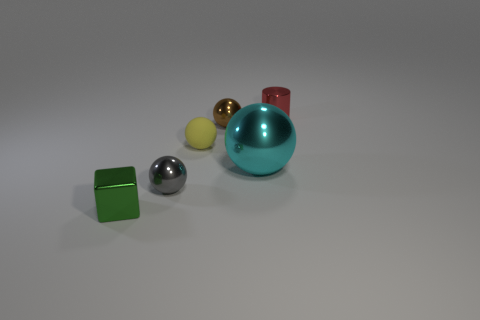Is there any other thing that is the same material as the small yellow thing?
Offer a terse response. No. Is the size of the ball that is to the right of the tiny brown sphere the same as the sphere that is behind the yellow sphere?
Your answer should be compact. No. Are there any red shiny objects of the same size as the cyan thing?
Your answer should be compact. No. Do the thing that is left of the tiny gray thing and the big cyan object have the same shape?
Give a very brief answer. No. What is the thing that is in front of the small gray ball made of?
Keep it short and to the point. Metal. What is the shape of the thing behind the tiny metal ball to the right of the gray shiny thing?
Provide a succinct answer. Cylinder. There is a large thing; is its shape the same as the tiny metallic thing that is to the right of the big cyan ball?
Make the answer very short. No. There is a metallic sphere in front of the cyan metal ball; how many metallic things are left of it?
Make the answer very short. 1. There is a big object that is the same shape as the tiny rubber thing; what is its material?
Offer a very short reply. Metal. What number of blue objects are metal balls or big things?
Your response must be concise. 0. 